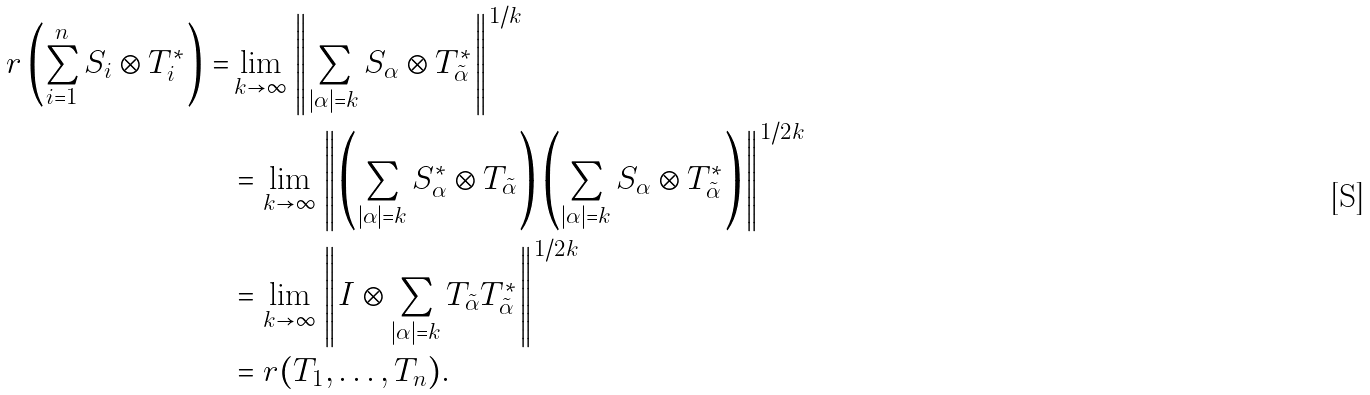Convert formula to latex. <formula><loc_0><loc_0><loc_500><loc_500>r \left ( \sum _ { i = 1 } ^ { n } S _ { i } \otimes T _ { i } ^ { * } \right ) = & \lim _ { k \to \infty } \left \| \sum _ { | \alpha | = k } S _ { \alpha } \otimes T _ { \tilde { \alpha } } ^ { * } \right \| ^ { 1 / k } \\ & = \lim _ { k \to \infty } \left \| \left ( \sum _ { | \alpha | = k } S _ { \alpha } ^ { * } \otimes T _ { \tilde { \alpha } } \right ) \left ( \sum _ { | \alpha | = k } S _ { \alpha } \otimes T _ { \tilde { \alpha } } ^ { * } \right ) \right \| ^ { 1 / 2 k } \\ & = \lim _ { k \to \infty } \left \| I \otimes \sum _ { | \alpha | = k } T _ { \tilde { \alpha } } T _ { \tilde { \alpha } } ^ { * } \right \| ^ { 1 / 2 k } \\ & = r ( T _ { 1 } , \dots , T _ { n } ) .</formula> 